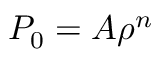Convert formula to latex. <formula><loc_0><loc_0><loc_500><loc_500>P _ { 0 } = A \rho ^ { n }</formula> 